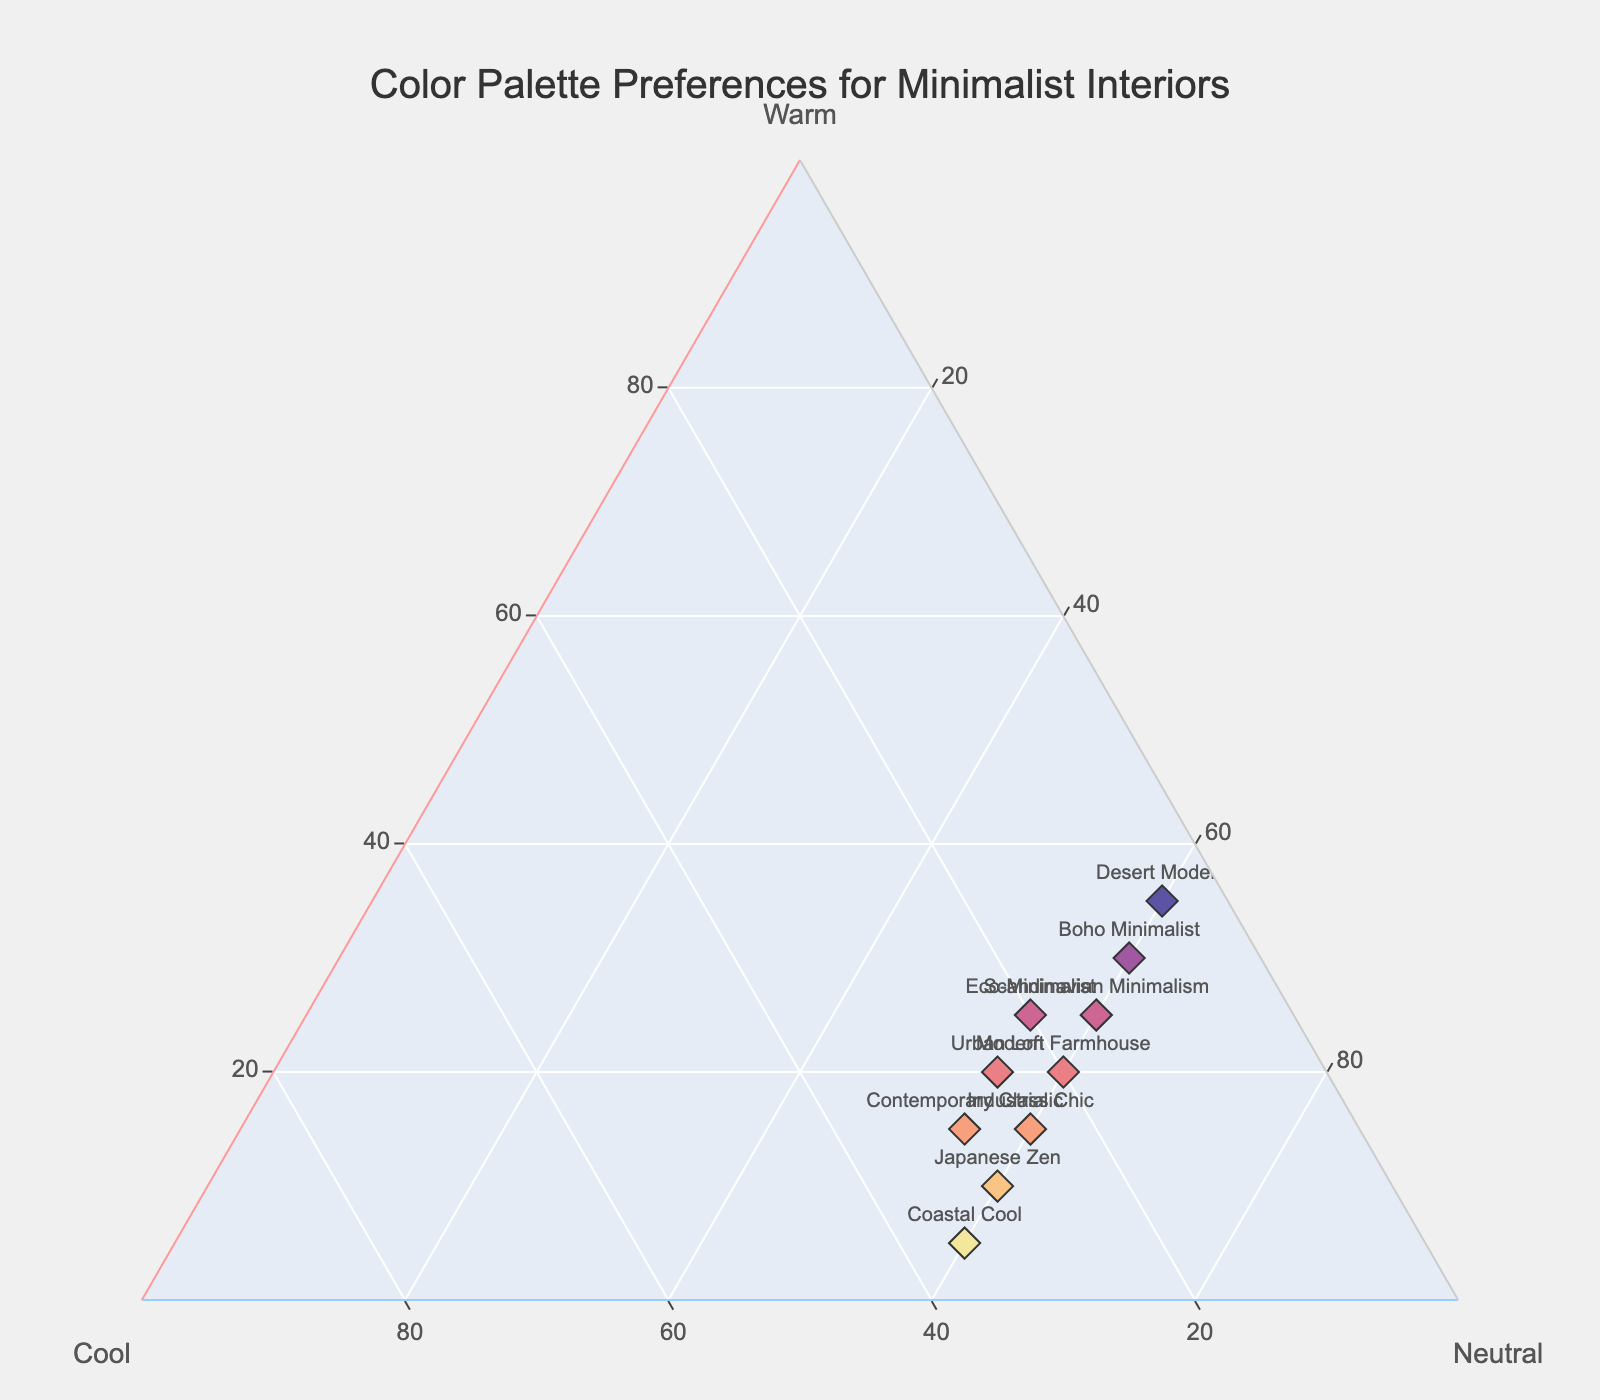What's the title of the figure? The title is prominently displayed at the top of the plot.
Answer: Color Palette Preferences for Minimalist Interiors How many data points are shown in the plot? Each unique style is represented by a single marker. Counting these markers gives the total number of data points.
Answer: 10 Which style has the highest preference for warm tones? By examining the 'Warm' axis, look for the marker positioned farthest along this axis.
Answer: Desert Modern What is the common percentage preference for neutral tones across all styles? By observing the 'Neutral' axis, which remains constant at 55 or 60 for all styles.
Answer: 55 or 60 Which style has the highest combined preference for cool and neutral tones? Sum the preferences for cool and neutral tones for each style, and identify the maximum. For example, Japanese Zen (30 + 60 = 90).
Answer: Japanese Zen Which style has the highest preference for cool tones? By examining the 'Cool' axis, identify the marker positioned farthest along this axis.
Answer: Coastal Cool Compare the warm tones preference between Scandinavian Minimalism and Boho Minimalist. Which has a higher preference? Identify the positions of Scandinavian Minimalism and Boho Minimalist along the warm tones axis. Compare the values.
Answer: Boho Minimalist What is the average percentage of warm tones across all styles? Sum the warm tones percentages and divide by the number of styles: (25 + 10 + 20 + 15 + 30 + 5 + 35 + 20 + 15 + 25) / 10
Answer: 20 Which style shows a balance between warm and cool tones, having nearly equal preferences for both? Check for styles where the values for warm and cool tones are almost equal, such as Scandinavian Minimalism (25, 15) and Modern Farmhouse (20, 20).
Answer: Modern Farmhouse What is the most common visual characteristic of the markers on the plot? Look for the general appearance of the markers on the plot, such as most having a size of 12 and a diamond symbol.
Answer: Diamond symbol and size 12 